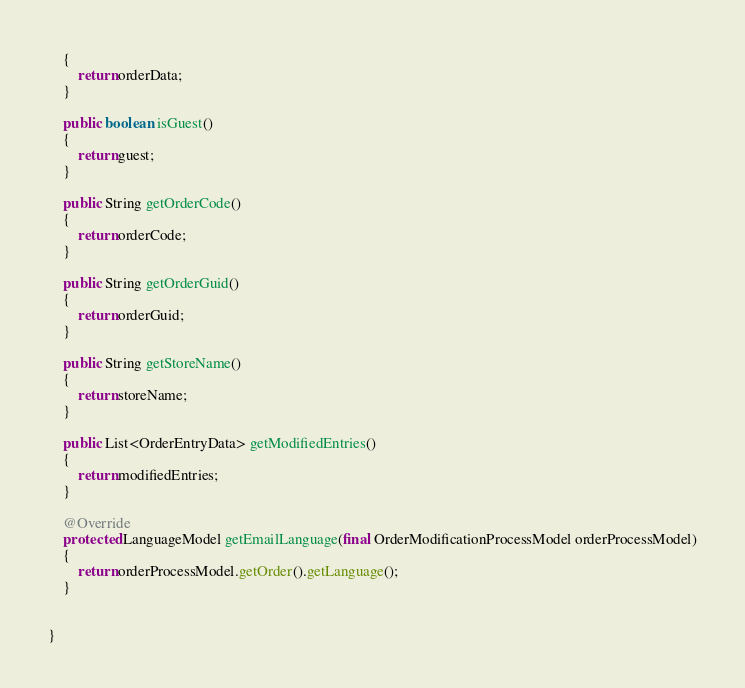Convert code to text. <code><loc_0><loc_0><loc_500><loc_500><_Java_>	{
		return orderData;
	}

	public boolean isGuest()
	{
		return guest;
	}

	public String getOrderCode()
	{
		return orderCode;
	}

	public String getOrderGuid()
	{
		return orderGuid;
	}

	public String getStoreName()
	{
		return storeName;
	}

	public List<OrderEntryData> getModifiedEntries()
	{
		return modifiedEntries;
	}

	@Override
	protected LanguageModel getEmailLanguage(final OrderModificationProcessModel orderProcessModel)
	{
		return orderProcessModel.getOrder().getLanguage();
	}


}
</code> 